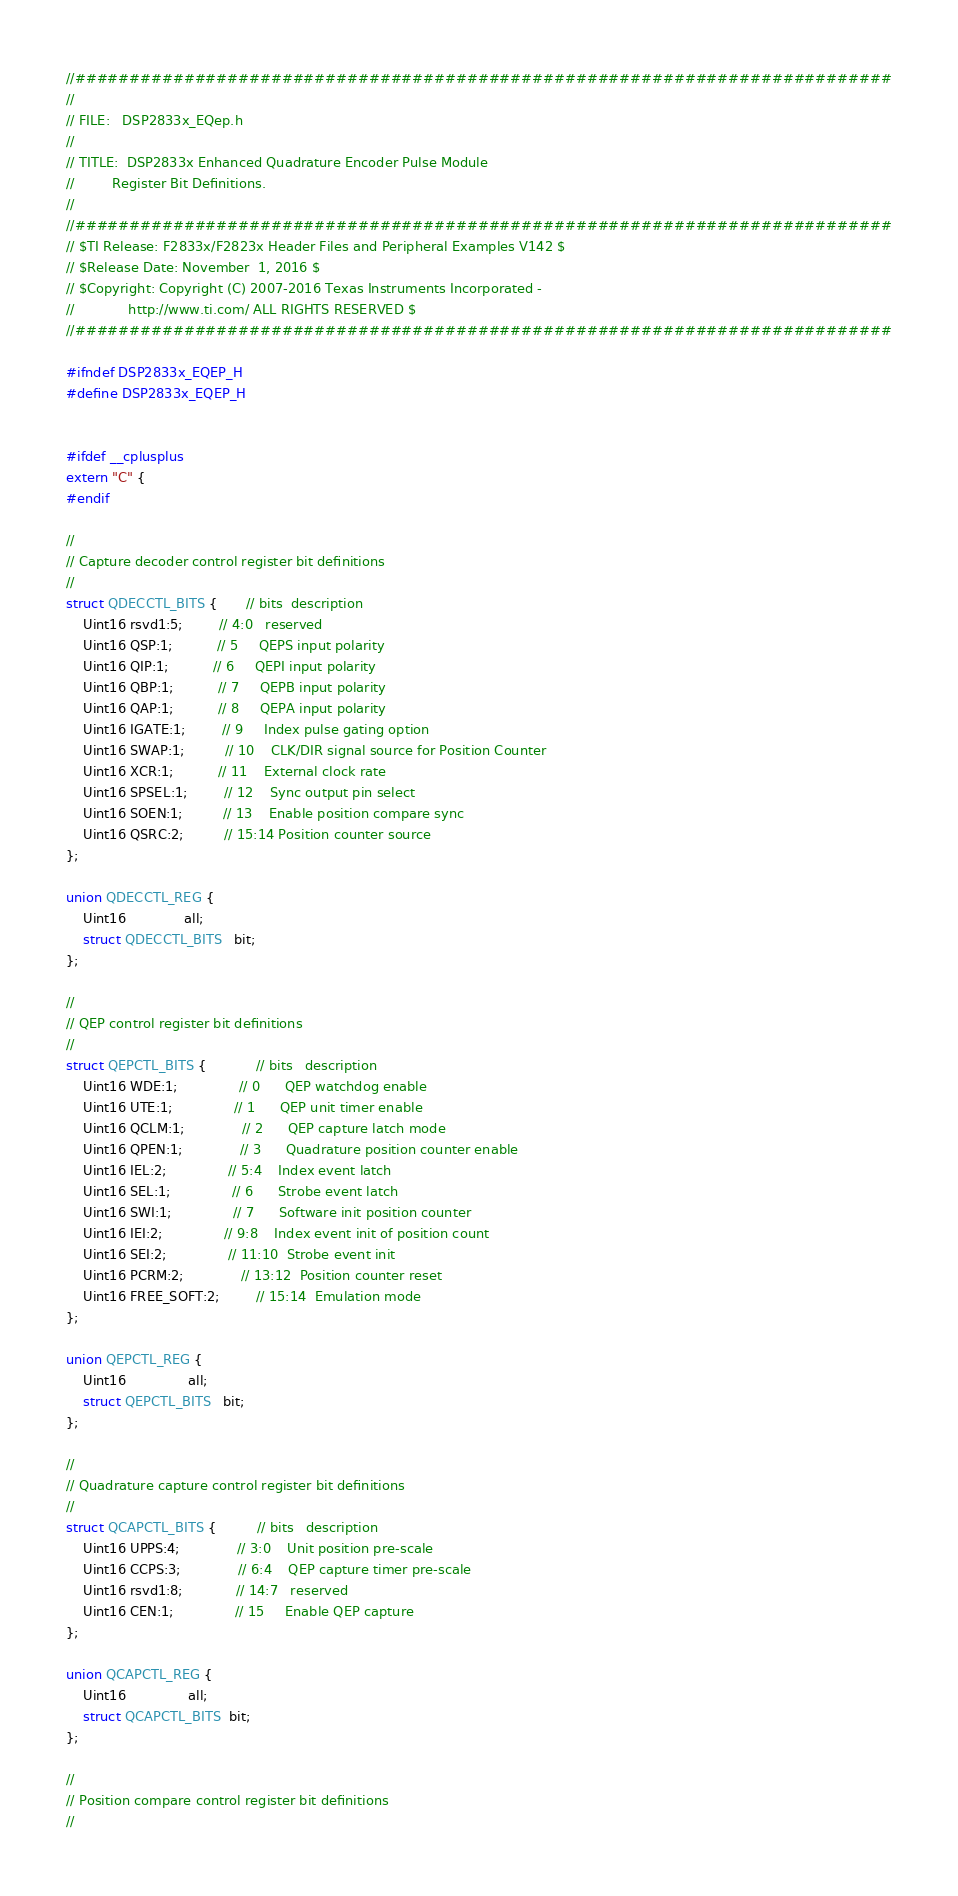<code> <loc_0><loc_0><loc_500><loc_500><_C_>//###########################################################################
//
// FILE:   DSP2833x_EQep.h
//
// TITLE:  DSP2833x Enhanced Quadrature Encoder Pulse Module 
//         Register Bit Definitions.
//
//###########################################################################
// $TI Release: F2833x/F2823x Header Files and Peripheral Examples V142 $
// $Release Date: November  1, 2016 $
// $Copyright: Copyright (C) 2007-2016 Texas Instruments Incorporated -
//             http://www.ti.com/ ALL RIGHTS RESERVED $
//###########################################################################

#ifndef DSP2833x_EQEP_H
#define DSP2833x_EQEP_H


#ifdef __cplusplus
extern "C" {
#endif

//
// Capture decoder control register bit definitions
//
struct QDECCTL_BITS {       // bits  description
    Uint16 rsvd1:5;         // 4:0   reserved
    Uint16 QSP:1;           // 5     QEPS input polarity
    Uint16 QIP:1;           // 6     QEPI input polarity
    Uint16 QBP:1;           // 7     QEPB input polarity
    Uint16 QAP:1;           // 8     QEPA input polarity
    Uint16 IGATE:1;         // 9     Index pulse gating option
    Uint16 SWAP:1;          // 10    CLK/DIR signal source for Position Counter
    Uint16 XCR:1;           // 11    External clock rate
    Uint16 SPSEL:1;         // 12    Sync output pin select
    Uint16 SOEN:1;          // 13    Enable position compare sync
    Uint16 QSRC:2;          // 15:14 Position counter source
};

union QDECCTL_REG {
    Uint16              all;
    struct QDECCTL_BITS   bit;
};

//
// QEP control register bit definitions
//
struct QEPCTL_BITS {            // bits   description
    Uint16 WDE:1;               // 0      QEP watchdog enable
    Uint16 UTE:1;               // 1      QEP unit timer enable
    Uint16 QCLM:1;              // 2      QEP capture latch mode
    Uint16 QPEN:1;              // 3      Quadrature position counter enable
    Uint16 IEL:2;               // 5:4    Index event latch
    Uint16 SEL:1;               // 6      Strobe event latch
    Uint16 SWI:1;               // 7      Software init position counter
    Uint16 IEI:2;               // 9:8    Index event init of position count
    Uint16 SEI:2;               // 11:10  Strobe event init
    Uint16 PCRM:2;              // 13:12  Position counter reset
    Uint16 FREE_SOFT:2;         // 15:14  Emulation mode
};

union QEPCTL_REG {
    Uint16               all;
    struct QEPCTL_BITS   bit;
};         

//
// Quadrature capture control register bit definitions
//
struct QCAPCTL_BITS {          // bits   description
    Uint16 UPPS:4;              // 3:0    Unit position pre-scale         
    Uint16 CCPS:3;              // 6:4    QEP capture timer pre-scale
    Uint16 rsvd1:8;             // 14:7   reserved
    Uint16 CEN:1;               // 15     Enable QEP capture
};

union QCAPCTL_REG {
    Uint16               all;
    struct QCAPCTL_BITS  bit;
}; 

//
// Position compare control register bit definitions
//</code> 